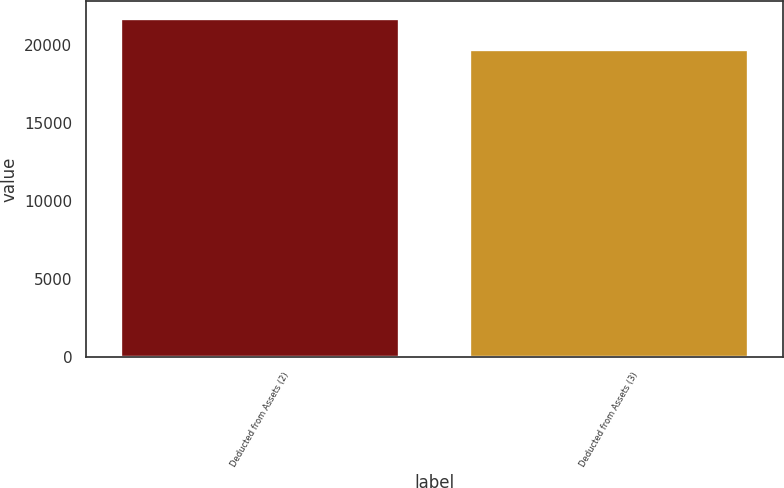Convert chart to OTSL. <chart><loc_0><loc_0><loc_500><loc_500><bar_chart><fcel>Deducted from Assets (2)<fcel>Deducted from Assets (3)<nl><fcel>21754<fcel>19784<nl></chart> 